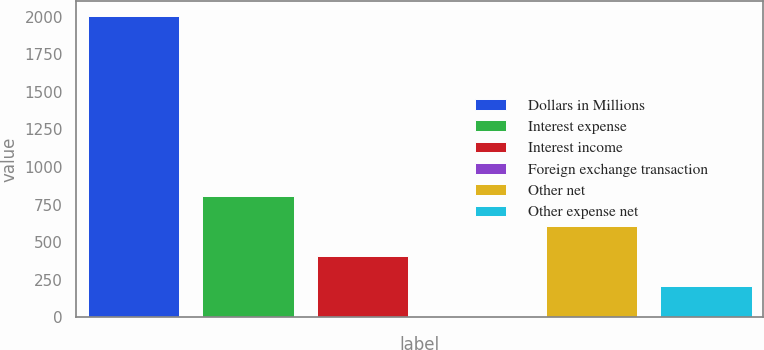Convert chart. <chart><loc_0><loc_0><loc_500><loc_500><bar_chart><fcel>Dollars in Millions<fcel>Interest expense<fcel>Interest income<fcel>Foreign exchange transaction<fcel>Other net<fcel>Other expense net<nl><fcel>2004<fcel>804.6<fcel>404.8<fcel>5<fcel>604.7<fcel>204.9<nl></chart> 